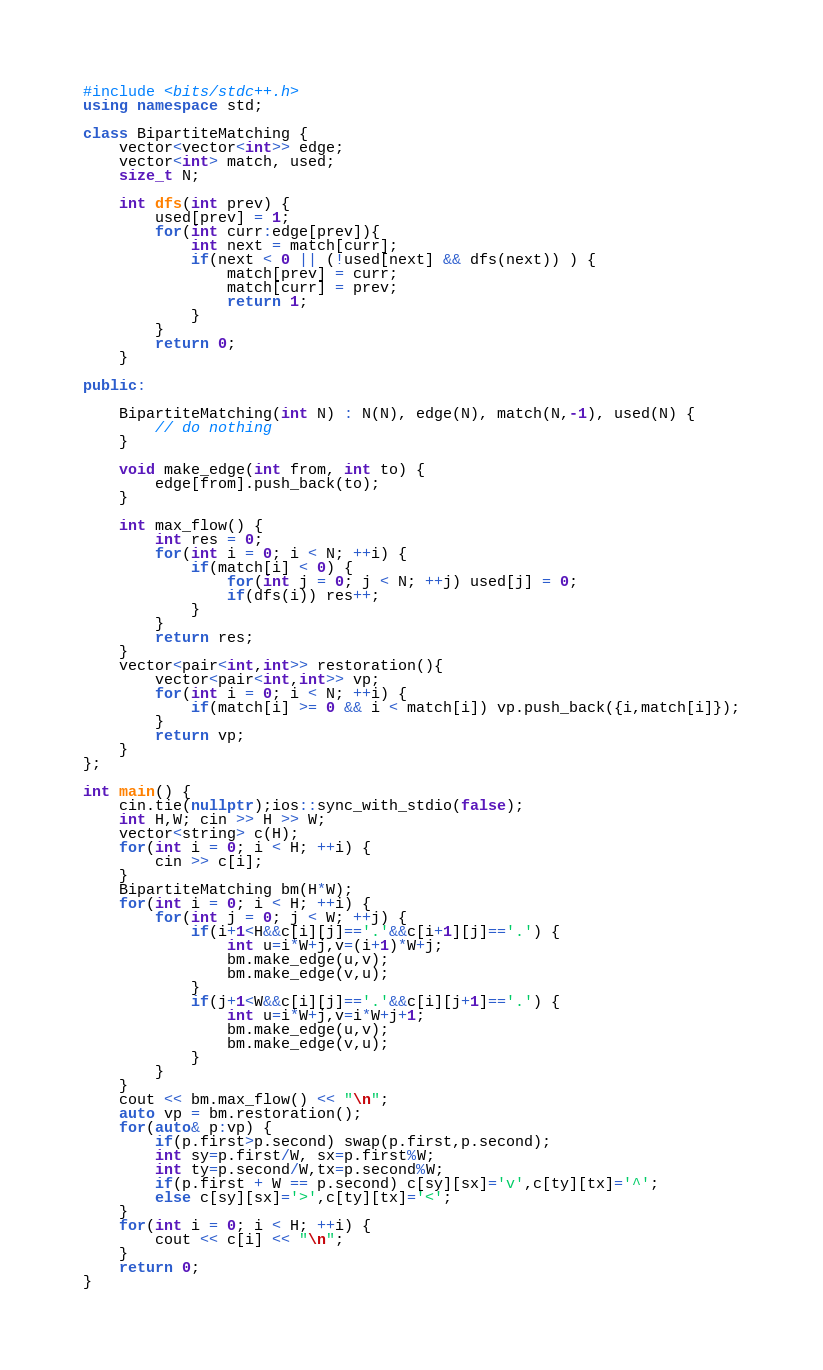Convert code to text. <code><loc_0><loc_0><loc_500><loc_500><_C++_>#include <bits/stdc++.h>
using namespace std;

class BipartiteMatching {
	vector<vector<int>> edge;
	vector<int> match, used;
    size_t N;

    int dfs(int prev) {
        used[prev] = 1;
        for(int curr:edge[prev]){
            int next = match[curr];
            if(next < 0 || (!used[next] && dfs(next)) ) {
                match[prev] = curr;
                match[curr] = prev;
                return 1;
            }
        }
        return 0;
    }

public:

	BipartiteMatching(int N) : N(N), edge(N), match(N,-1), used(N) {
		// do nothing
	}

	void make_edge(int from, int to) {
		edge[from].push_back(to);
	}

	int max_flow() {
		int res = 0;
        for(int i = 0; i < N; ++i) {
            if(match[i] < 0) {
                for(int j = 0; j < N; ++j) used[j] = 0;
                if(dfs(i)) res++;
            }
        }
        return res;
	}
    vector<pair<int,int>> restoration(){
        vector<pair<int,int>> vp;
        for(int i = 0; i < N; ++i) {
            if(match[i] >= 0 && i < match[i]) vp.push_back({i,match[i]});
        }
        return vp;
    }
};

int main() {
    cin.tie(nullptr);ios::sync_with_stdio(false);
    int H,W; cin >> H >> W;
    vector<string> c(H);
    for(int i = 0; i < H; ++i) {
        cin >> c[i];
    }    
    BipartiteMatching bm(H*W);
    for(int i = 0; i < H; ++i) {
        for(int j = 0; j < W; ++j) {
            if(i+1<H&&c[i][j]=='.'&&c[i+1][j]=='.') {
                int u=i*W+j,v=(i+1)*W+j;
                bm.make_edge(u,v);
                bm.make_edge(v,u);
            }
            if(j+1<W&&c[i][j]=='.'&&c[i][j+1]=='.') {
                int u=i*W+j,v=i*W+j+1;
                bm.make_edge(u,v);
                bm.make_edge(v,u);
            }
        }
    }    
    cout << bm.max_flow() << "\n";
    auto vp = bm.restoration();
    for(auto& p:vp) {
        if(p.first>p.second) swap(p.first,p.second);
        int sy=p.first/W, sx=p.first%W;
        int ty=p.second/W,tx=p.second%W;
        if(p.first + W == p.second) c[sy][sx]='v',c[ty][tx]='^';
        else c[sy][sx]='>',c[ty][tx]='<';
    }
    for(int i = 0; i < H; ++i) {
        cout << c[i] << "\n";
    }    
    return 0;
}</code> 